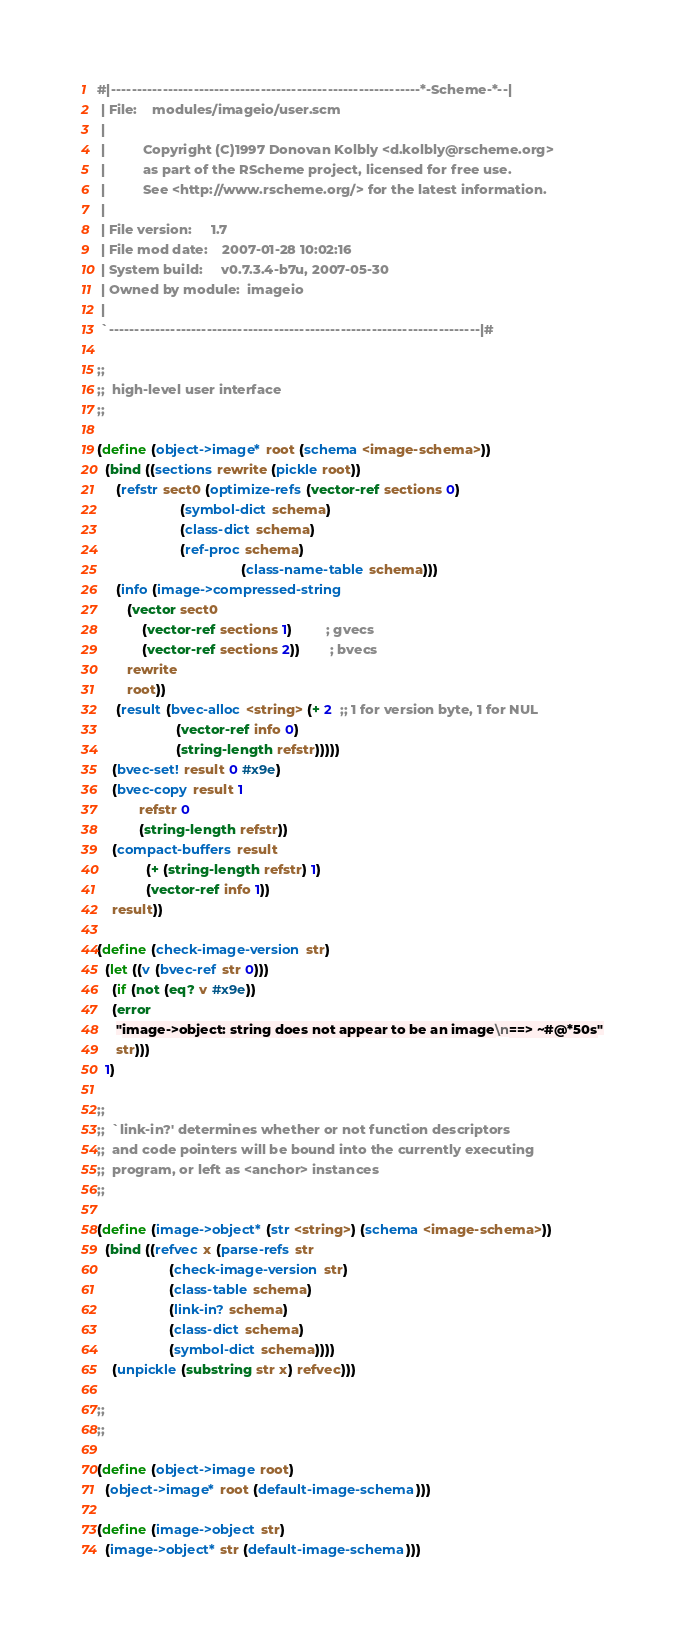<code> <loc_0><loc_0><loc_500><loc_500><_Scheme_>#|------------------------------------------------------------*-Scheme-*--|
 | File:    modules/imageio/user.scm
 |
 |          Copyright (C)1997 Donovan Kolbly <d.kolbly@rscheme.org>
 |          as part of the RScheme project, licensed for free use.
 |          See <http://www.rscheme.org/> for the latest information.
 |
 | File version:     1.7
 | File mod date:    2007-01-28 10:02:16
 | System build:     v0.7.3.4-b7u, 2007-05-30
 | Owned by module:  imageio
 |
 `------------------------------------------------------------------------|#

;;
;;  high-level user interface
;;

(define (object->image* root (schema <image-schema>))
  (bind ((sections rewrite (pickle root))
	 (refstr sect0 (optimize-refs (vector-ref sections 0)
				      (symbol-dict schema)
				      (class-dict schema)
				      (ref-proc schema)
                                      (class-name-table schema)))
	 (info (image->compressed-string
		(vector sect0
			(vector-ref sections 1)         ; gvecs
			(vector-ref sections 2))        ; bvecs
		rewrite
		root))
	 (result (bvec-alloc <string> (+ 2  ;; 1 for version byte, 1 for NUL
					 (vector-ref info 0)
					 (string-length refstr)))))
    (bvec-set! result 0 #x9e)
    (bvec-copy result 1 
	       refstr 0 
	       (string-length refstr))
    (compact-buffers result
		     (+ (string-length refstr) 1)
		     (vector-ref info 1))
    result))

(define (check-image-version str)
  (let ((v (bvec-ref str 0)))
    (if (not (eq? v #x9e))
	(error 
	 "image->object: string does not appear to be an image\n==> ~#@*50s" 
	 str)))
  1)

;;
;;  `link-in?' determines whether or not function descriptors
;;  and code pointers will be bound into the currently executing
;;  program, or left as <anchor> instances
;;

(define (image->object* (str <string>) (schema <image-schema>))
  (bind ((refvec x (parse-refs str 
			       (check-image-version str)
			       (class-table schema)
			       (link-in? schema)
			       (class-dict schema)
			       (symbol-dict schema))))
    (unpickle (substring str x) refvec)))

;;
;;

(define (object->image root)
  (object->image* root (default-image-schema)))

(define (image->object str)
  (image->object* str (default-image-schema)))
</code> 